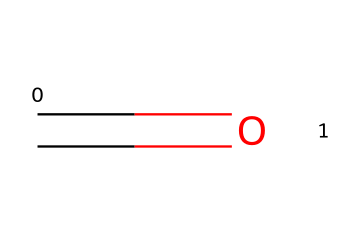What is the name of this chemical? The SMILES representation C=O indicates a carbonyl group, and since it has a hydrogen attached to the carbon, it is classified as formaldehyde, which is the simplest aldehyde.
Answer: formaldehyde How many carbon atoms are in this molecule? The SMILES structure shows one carbon atom (C) connected to an oxygen atom through a double bond and has a hydrogen. Therefore, there is only one carbon atom present.
Answer: one What type of functional group does this structure contain? The C=O notation indicates a carbonyl group, which is characteristic of aldehydes. Since it is at the end of a carbon chain, it is specifically an aldehyde functional group.
Answer: carbonyl group Does this compound contain any hydroxyl groups? The SMILES representation does not show an -OH group, which is indicative of hydroxyl groups. Therefore, this compound does not contain hydroxyl groups.
Answer: no What is the bond type between carbon and oxygen in this molecule? The representation C=O indicates a double bond (C=O), which illustrates that there is a double bond between the carbon and oxygen atoms in this molecule.
Answer: double bond Is this compound considered a toxic substance? Formaldehyde is known to be toxic, especially in higher concentrations, which is why it is handled with caution in cleaning products. This characteristic qualifies it as a toxic substance.
Answer: toxic 